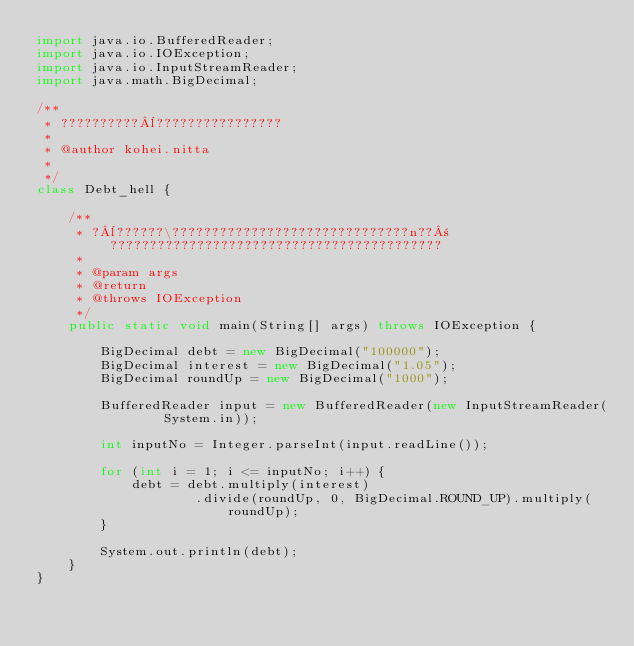<code> <loc_0><loc_0><loc_500><loc_500><_Java_>import java.io.BufferedReader;
import java.io.IOException;
import java.io.InputStreamReader;
import java.math.BigDecimal;

/**
 * ??????????¨????????????????
 *
 * @author kohei.nitta
 *
 */
class Debt_hell {

	/**
	 * ?¨??????\??????????????????????????????n??±??????????????????????????????????????????
	 *
	 * @param args
	 * @return
	 * @throws IOException
	 */
	public static void main(String[] args) throws IOException {

		BigDecimal debt = new BigDecimal("100000");
		BigDecimal interest = new BigDecimal("1.05");
		BigDecimal roundUp = new BigDecimal("1000");

		BufferedReader input = new BufferedReader(new InputStreamReader(
				System.in));

		int inputNo = Integer.parseInt(input.readLine());

		for (int i = 1; i <= inputNo; i++) {
			debt = debt.multiply(interest)
					.divide(roundUp, 0, BigDecimal.ROUND_UP).multiply(roundUp);
		}

		System.out.println(debt);
	}
}</code> 